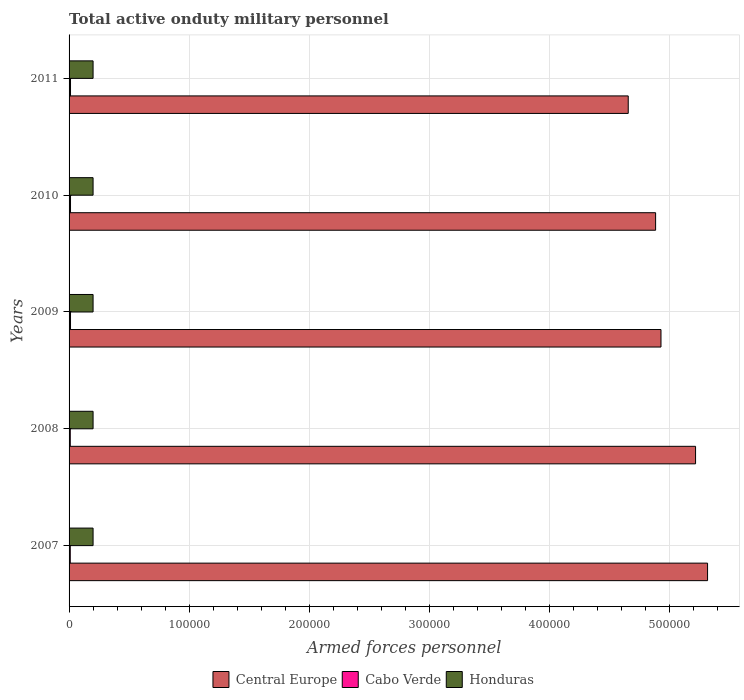Are the number of bars per tick equal to the number of legend labels?
Give a very brief answer. Yes. Are the number of bars on each tick of the Y-axis equal?
Your answer should be compact. Yes. In how many cases, is the number of bars for a given year not equal to the number of legend labels?
Make the answer very short. 0. What is the number of armed forces personnel in Honduras in 2007?
Your answer should be very brief. 2.00e+04. Across all years, what is the maximum number of armed forces personnel in Central Europe?
Your answer should be very brief. 5.32e+05. In which year was the number of armed forces personnel in Central Europe minimum?
Your answer should be very brief. 2011. What is the total number of armed forces personnel in Central Europe in the graph?
Ensure brevity in your answer.  2.50e+06. What is the difference between the number of armed forces personnel in Cabo Verde in 2007 and that in 2011?
Ensure brevity in your answer.  -200. What is the difference between the number of armed forces personnel in Honduras in 2009 and the number of armed forces personnel in Cabo Verde in 2011?
Your answer should be compact. 1.88e+04. What is the average number of armed forces personnel in Cabo Verde per year?
Make the answer very short. 1120. In the year 2007, what is the difference between the number of armed forces personnel in Central Europe and number of armed forces personnel in Honduras?
Your answer should be very brief. 5.12e+05. What is the ratio of the number of armed forces personnel in Cabo Verde in 2007 to that in 2009?
Ensure brevity in your answer.  0.83. What is the difference between the highest and the lowest number of armed forces personnel in Honduras?
Offer a terse response. 0. Is the sum of the number of armed forces personnel in Honduras in 2010 and 2011 greater than the maximum number of armed forces personnel in Cabo Verde across all years?
Provide a succinct answer. Yes. What does the 1st bar from the top in 2007 represents?
Your answer should be very brief. Honduras. What does the 2nd bar from the bottom in 2009 represents?
Your answer should be compact. Cabo Verde. Are all the bars in the graph horizontal?
Your answer should be compact. Yes. What is the difference between two consecutive major ticks on the X-axis?
Your response must be concise. 1.00e+05. Are the values on the major ticks of X-axis written in scientific E-notation?
Offer a very short reply. No. Does the graph contain grids?
Offer a terse response. Yes. How many legend labels are there?
Offer a terse response. 3. What is the title of the graph?
Keep it short and to the point. Total active onduty military personnel. What is the label or title of the X-axis?
Give a very brief answer. Armed forces personnel. What is the label or title of the Y-axis?
Provide a short and direct response. Years. What is the Armed forces personnel in Central Europe in 2007?
Provide a succinct answer. 5.32e+05. What is the Armed forces personnel in Cabo Verde in 2007?
Ensure brevity in your answer.  1000. What is the Armed forces personnel in Central Europe in 2008?
Provide a short and direct response. 5.22e+05. What is the Armed forces personnel in Honduras in 2008?
Offer a terse response. 2.00e+04. What is the Armed forces personnel of Central Europe in 2009?
Provide a short and direct response. 4.93e+05. What is the Armed forces personnel in Cabo Verde in 2009?
Ensure brevity in your answer.  1200. What is the Armed forces personnel of Central Europe in 2010?
Ensure brevity in your answer.  4.89e+05. What is the Armed forces personnel in Cabo Verde in 2010?
Offer a very short reply. 1200. What is the Armed forces personnel of Central Europe in 2011?
Your answer should be very brief. 4.66e+05. What is the Armed forces personnel in Cabo Verde in 2011?
Provide a succinct answer. 1200. Across all years, what is the maximum Armed forces personnel of Central Europe?
Give a very brief answer. 5.32e+05. Across all years, what is the maximum Armed forces personnel in Cabo Verde?
Your response must be concise. 1200. Across all years, what is the minimum Armed forces personnel of Central Europe?
Give a very brief answer. 4.66e+05. What is the total Armed forces personnel in Central Europe in the graph?
Keep it short and to the point. 2.50e+06. What is the total Armed forces personnel in Cabo Verde in the graph?
Offer a very short reply. 5600. What is the total Armed forces personnel of Honduras in the graph?
Offer a terse response. 1.00e+05. What is the difference between the Armed forces personnel of Honduras in 2007 and that in 2008?
Your answer should be very brief. 0. What is the difference between the Armed forces personnel of Central Europe in 2007 and that in 2009?
Your response must be concise. 3.88e+04. What is the difference between the Armed forces personnel of Cabo Verde in 2007 and that in 2009?
Your answer should be very brief. -200. What is the difference between the Armed forces personnel of Honduras in 2007 and that in 2009?
Ensure brevity in your answer.  0. What is the difference between the Armed forces personnel of Central Europe in 2007 and that in 2010?
Offer a terse response. 4.33e+04. What is the difference between the Armed forces personnel in Cabo Verde in 2007 and that in 2010?
Provide a succinct answer. -200. What is the difference between the Armed forces personnel in Central Europe in 2007 and that in 2011?
Your answer should be compact. 6.61e+04. What is the difference between the Armed forces personnel of Cabo Verde in 2007 and that in 2011?
Offer a terse response. -200. What is the difference between the Armed forces personnel of Honduras in 2007 and that in 2011?
Your answer should be very brief. 0. What is the difference between the Armed forces personnel in Central Europe in 2008 and that in 2009?
Your response must be concise. 2.88e+04. What is the difference between the Armed forces personnel in Cabo Verde in 2008 and that in 2009?
Offer a very short reply. -200. What is the difference between the Armed forces personnel in Honduras in 2008 and that in 2009?
Your response must be concise. 0. What is the difference between the Armed forces personnel of Central Europe in 2008 and that in 2010?
Your answer should be compact. 3.33e+04. What is the difference between the Armed forces personnel of Cabo Verde in 2008 and that in 2010?
Your answer should be compact. -200. What is the difference between the Armed forces personnel of Central Europe in 2008 and that in 2011?
Give a very brief answer. 5.61e+04. What is the difference between the Armed forces personnel in Cabo Verde in 2008 and that in 2011?
Provide a succinct answer. -200. What is the difference between the Armed forces personnel in Central Europe in 2009 and that in 2010?
Provide a succinct answer. 4481. What is the difference between the Armed forces personnel in Honduras in 2009 and that in 2010?
Your answer should be compact. 0. What is the difference between the Armed forces personnel in Central Europe in 2009 and that in 2011?
Make the answer very short. 2.73e+04. What is the difference between the Armed forces personnel of Central Europe in 2010 and that in 2011?
Provide a succinct answer. 2.28e+04. What is the difference between the Armed forces personnel of Central Europe in 2007 and the Armed forces personnel of Cabo Verde in 2008?
Your answer should be compact. 5.31e+05. What is the difference between the Armed forces personnel in Central Europe in 2007 and the Armed forces personnel in Honduras in 2008?
Keep it short and to the point. 5.12e+05. What is the difference between the Armed forces personnel in Cabo Verde in 2007 and the Armed forces personnel in Honduras in 2008?
Provide a succinct answer. -1.90e+04. What is the difference between the Armed forces personnel in Central Europe in 2007 and the Armed forces personnel in Cabo Verde in 2009?
Offer a terse response. 5.31e+05. What is the difference between the Armed forces personnel in Central Europe in 2007 and the Armed forces personnel in Honduras in 2009?
Provide a short and direct response. 5.12e+05. What is the difference between the Armed forces personnel in Cabo Verde in 2007 and the Armed forces personnel in Honduras in 2009?
Make the answer very short. -1.90e+04. What is the difference between the Armed forces personnel of Central Europe in 2007 and the Armed forces personnel of Cabo Verde in 2010?
Your answer should be very brief. 5.31e+05. What is the difference between the Armed forces personnel in Central Europe in 2007 and the Armed forces personnel in Honduras in 2010?
Offer a terse response. 5.12e+05. What is the difference between the Armed forces personnel in Cabo Verde in 2007 and the Armed forces personnel in Honduras in 2010?
Your answer should be very brief. -1.90e+04. What is the difference between the Armed forces personnel in Central Europe in 2007 and the Armed forces personnel in Cabo Verde in 2011?
Make the answer very short. 5.31e+05. What is the difference between the Armed forces personnel in Central Europe in 2007 and the Armed forces personnel in Honduras in 2011?
Provide a short and direct response. 5.12e+05. What is the difference between the Armed forces personnel of Cabo Verde in 2007 and the Armed forces personnel of Honduras in 2011?
Give a very brief answer. -1.90e+04. What is the difference between the Armed forces personnel in Central Europe in 2008 and the Armed forces personnel in Cabo Verde in 2009?
Your answer should be very brief. 5.21e+05. What is the difference between the Armed forces personnel of Central Europe in 2008 and the Armed forces personnel of Honduras in 2009?
Keep it short and to the point. 5.02e+05. What is the difference between the Armed forces personnel in Cabo Verde in 2008 and the Armed forces personnel in Honduras in 2009?
Offer a very short reply. -1.90e+04. What is the difference between the Armed forces personnel in Central Europe in 2008 and the Armed forces personnel in Cabo Verde in 2010?
Offer a terse response. 5.21e+05. What is the difference between the Armed forces personnel of Central Europe in 2008 and the Armed forces personnel of Honduras in 2010?
Give a very brief answer. 5.02e+05. What is the difference between the Armed forces personnel in Cabo Verde in 2008 and the Armed forces personnel in Honduras in 2010?
Your response must be concise. -1.90e+04. What is the difference between the Armed forces personnel in Central Europe in 2008 and the Armed forces personnel in Cabo Verde in 2011?
Your answer should be compact. 5.21e+05. What is the difference between the Armed forces personnel of Central Europe in 2008 and the Armed forces personnel of Honduras in 2011?
Make the answer very short. 5.02e+05. What is the difference between the Armed forces personnel of Cabo Verde in 2008 and the Armed forces personnel of Honduras in 2011?
Your answer should be compact. -1.90e+04. What is the difference between the Armed forces personnel in Central Europe in 2009 and the Armed forces personnel in Cabo Verde in 2010?
Your answer should be compact. 4.92e+05. What is the difference between the Armed forces personnel in Central Europe in 2009 and the Armed forces personnel in Honduras in 2010?
Offer a terse response. 4.73e+05. What is the difference between the Armed forces personnel in Cabo Verde in 2009 and the Armed forces personnel in Honduras in 2010?
Offer a terse response. -1.88e+04. What is the difference between the Armed forces personnel in Central Europe in 2009 and the Armed forces personnel in Cabo Verde in 2011?
Your answer should be compact. 4.92e+05. What is the difference between the Armed forces personnel of Central Europe in 2009 and the Armed forces personnel of Honduras in 2011?
Keep it short and to the point. 4.73e+05. What is the difference between the Armed forces personnel of Cabo Verde in 2009 and the Armed forces personnel of Honduras in 2011?
Your answer should be very brief. -1.88e+04. What is the difference between the Armed forces personnel of Central Europe in 2010 and the Armed forces personnel of Cabo Verde in 2011?
Keep it short and to the point. 4.88e+05. What is the difference between the Armed forces personnel of Central Europe in 2010 and the Armed forces personnel of Honduras in 2011?
Offer a very short reply. 4.69e+05. What is the difference between the Armed forces personnel in Cabo Verde in 2010 and the Armed forces personnel in Honduras in 2011?
Your answer should be compact. -1.88e+04. What is the average Armed forces personnel in Central Europe per year?
Keep it short and to the point. 5.00e+05. What is the average Armed forces personnel of Cabo Verde per year?
Provide a short and direct response. 1120. In the year 2007, what is the difference between the Armed forces personnel in Central Europe and Armed forces personnel in Cabo Verde?
Provide a succinct answer. 5.31e+05. In the year 2007, what is the difference between the Armed forces personnel of Central Europe and Armed forces personnel of Honduras?
Offer a terse response. 5.12e+05. In the year 2007, what is the difference between the Armed forces personnel in Cabo Verde and Armed forces personnel in Honduras?
Your answer should be compact. -1.90e+04. In the year 2008, what is the difference between the Armed forces personnel of Central Europe and Armed forces personnel of Cabo Verde?
Give a very brief answer. 5.21e+05. In the year 2008, what is the difference between the Armed forces personnel in Central Europe and Armed forces personnel in Honduras?
Your answer should be very brief. 5.02e+05. In the year 2008, what is the difference between the Armed forces personnel in Cabo Verde and Armed forces personnel in Honduras?
Your answer should be compact. -1.90e+04. In the year 2009, what is the difference between the Armed forces personnel in Central Europe and Armed forces personnel in Cabo Verde?
Make the answer very short. 4.92e+05. In the year 2009, what is the difference between the Armed forces personnel of Central Europe and Armed forces personnel of Honduras?
Your answer should be very brief. 4.73e+05. In the year 2009, what is the difference between the Armed forces personnel of Cabo Verde and Armed forces personnel of Honduras?
Ensure brevity in your answer.  -1.88e+04. In the year 2010, what is the difference between the Armed forces personnel of Central Europe and Armed forces personnel of Cabo Verde?
Provide a succinct answer. 4.88e+05. In the year 2010, what is the difference between the Armed forces personnel of Central Europe and Armed forces personnel of Honduras?
Your answer should be very brief. 4.69e+05. In the year 2010, what is the difference between the Armed forces personnel in Cabo Verde and Armed forces personnel in Honduras?
Your answer should be compact. -1.88e+04. In the year 2011, what is the difference between the Armed forces personnel in Central Europe and Armed forces personnel in Cabo Verde?
Provide a succinct answer. 4.65e+05. In the year 2011, what is the difference between the Armed forces personnel in Central Europe and Armed forces personnel in Honduras?
Your response must be concise. 4.46e+05. In the year 2011, what is the difference between the Armed forces personnel of Cabo Verde and Armed forces personnel of Honduras?
Provide a short and direct response. -1.88e+04. What is the ratio of the Armed forces personnel of Central Europe in 2007 to that in 2008?
Keep it short and to the point. 1.02. What is the ratio of the Armed forces personnel in Cabo Verde in 2007 to that in 2008?
Give a very brief answer. 1. What is the ratio of the Armed forces personnel of Central Europe in 2007 to that in 2009?
Keep it short and to the point. 1.08. What is the ratio of the Armed forces personnel of Central Europe in 2007 to that in 2010?
Keep it short and to the point. 1.09. What is the ratio of the Armed forces personnel in Cabo Verde in 2007 to that in 2010?
Your response must be concise. 0.83. What is the ratio of the Armed forces personnel of Honduras in 2007 to that in 2010?
Provide a succinct answer. 1. What is the ratio of the Armed forces personnel in Central Europe in 2007 to that in 2011?
Provide a succinct answer. 1.14. What is the ratio of the Armed forces personnel of Central Europe in 2008 to that in 2009?
Make the answer very short. 1.06. What is the ratio of the Armed forces personnel in Central Europe in 2008 to that in 2010?
Ensure brevity in your answer.  1.07. What is the ratio of the Armed forces personnel of Cabo Verde in 2008 to that in 2010?
Offer a very short reply. 0.83. What is the ratio of the Armed forces personnel in Honduras in 2008 to that in 2010?
Offer a terse response. 1. What is the ratio of the Armed forces personnel of Central Europe in 2008 to that in 2011?
Make the answer very short. 1.12. What is the ratio of the Armed forces personnel in Central Europe in 2009 to that in 2010?
Give a very brief answer. 1.01. What is the ratio of the Armed forces personnel in Honduras in 2009 to that in 2010?
Give a very brief answer. 1. What is the ratio of the Armed forces personnel in Central Europe in 2009 to that in 2011?
Give a very brief answer. 1.06. What is the ratio of the Armed forces personnel in Cabo Verde in 2009 to that in 2011?
Your answer should be very brief. 1. What is the ratio of the Armed forces personnel in Central Europe in 2010 to that in 2011?
Give a very brief answer. 1.05. What is the ratio of the Armed forces personnel of Cabo Verde in 2010 to that in 2011?
Ensure brevity in your answer.  1. What is the ratio of the Armed forces personnel of Honduras in 2010 to that in 2011?
Offer a very short reply. 1. What is the difference between the highest and the second highest Armed forces personnel in Honduras?
Make the answer very short. 0. What is the difference between the highest and the lowest Armed forces personnel of Central Europe?
Give a very brief answer. 6.61e+04. What is the difference between the highest and the lowest Armed forces personnel of Honduras?
Provide a short and direct response. 0. 